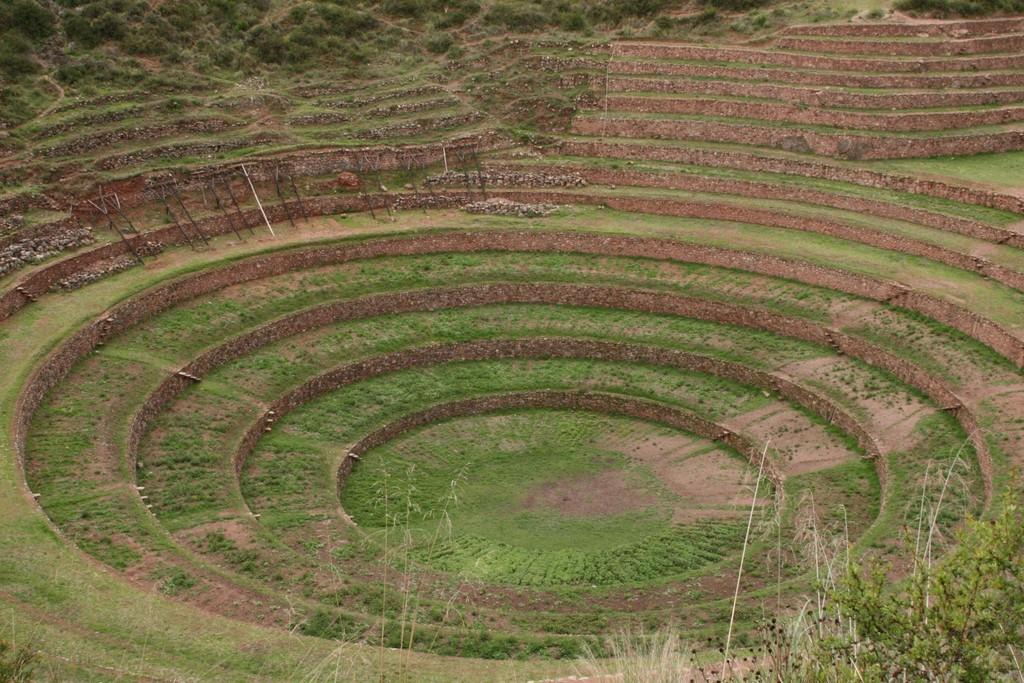What type of surface can be seen in the image? There is ground visible in the image. What is the color and texture of the ground? The ground has green grass. What else is present on the ground? There are plants on the ground. Can you describe the unspecified "things" in the image? Unfortunately, the facts provided do not give any details about the "things" in the image. What type of vessel is being used to blow bubbles in the image? There is no vessel or bubbles present in the image. 